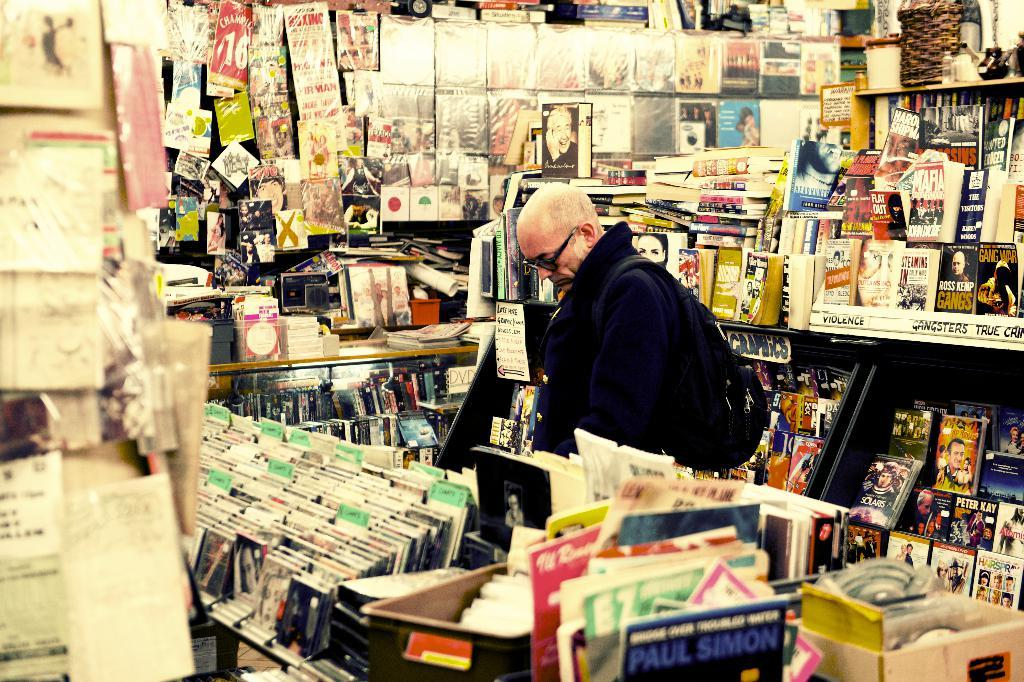<image>
Offer a succinct explanation of the picture presented. A man in a store that has paul simon and other cds 